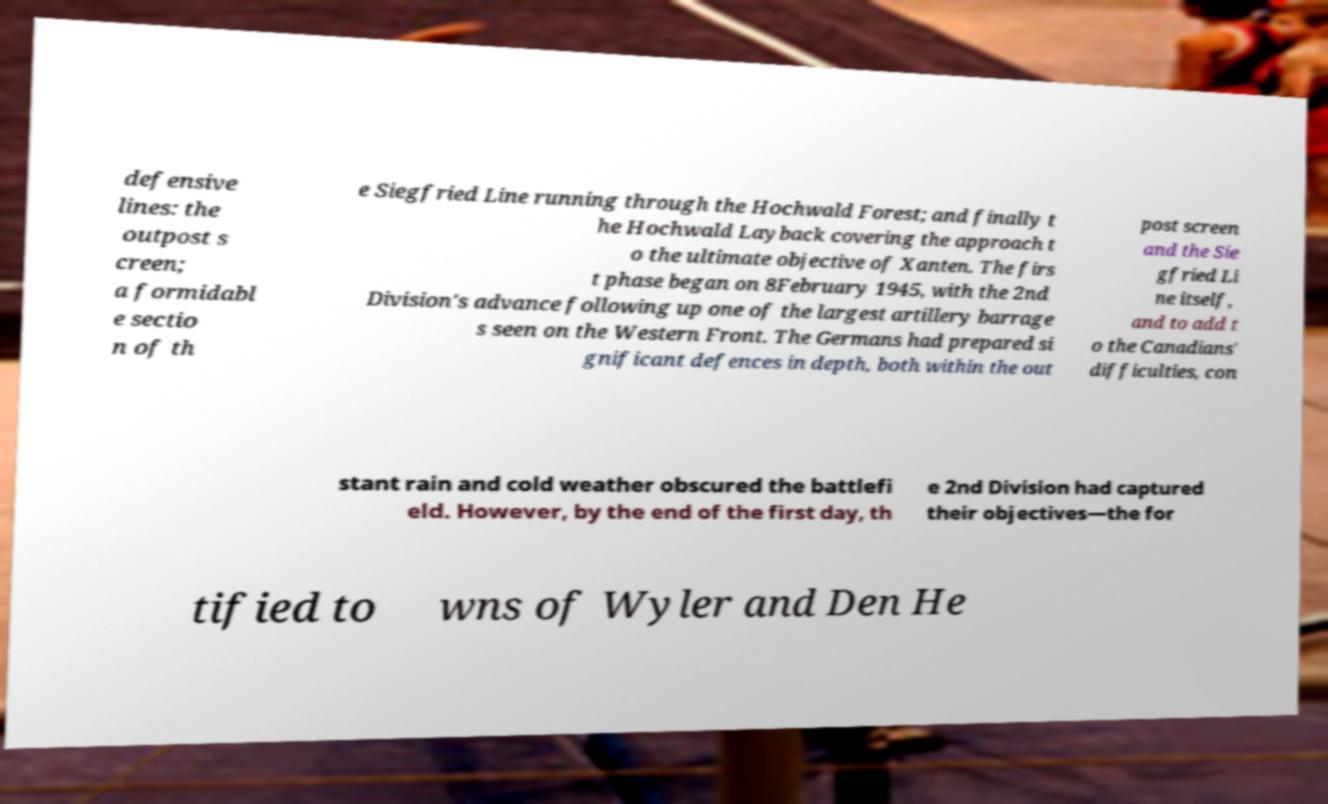What messages or text are displayed in this image? I need them in a readable, typed format. defensive lines: the outpost s creen; a formidabl e sectio n of th e Siegfried Line running through the Hochwald Forest; and finally t he Hochwald Layback covering the approach t o the ultimate objective of Xanten. The firs t phase began on 8February 1945, with the 2nd Division's advance following up one of the largest artillery barrage s seen on the Western Front. The Germans had prepared si gnificant defences in depth, both within the out post screen and the Sie gfried Li ne itself, and to add t o the Canadians' difficulties, con stant rain and cold weather obscured the battlefi eld. However, by the end of the first day, th e 2nd Division had captured their objectives—the for tified to wns of Wyler and Den He 